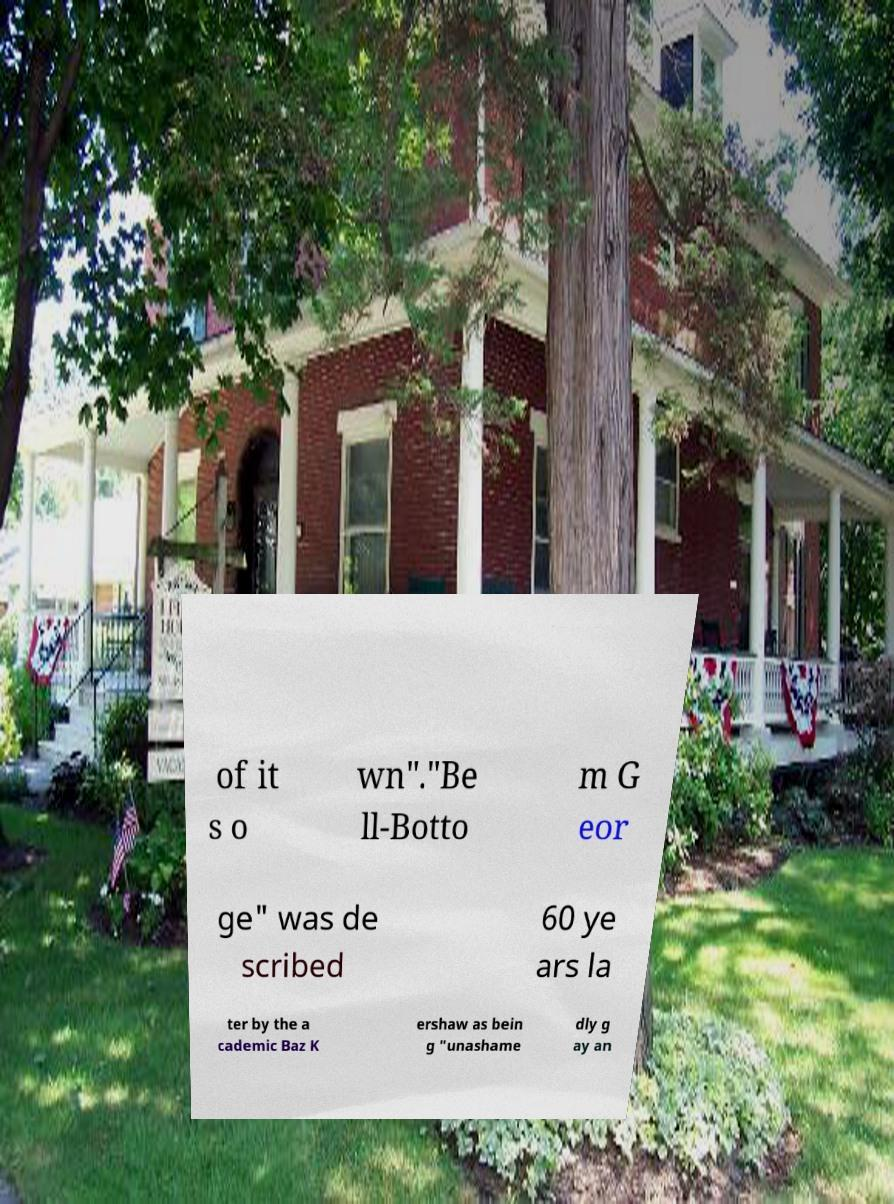Could you extract and type out the text from this image? of it s o wn"."Be ll-Botto m G eor ge" was de scribed 60 ye ars la ter by the a cademic Baz K ershaw as bein g "unashame dly g ay an 